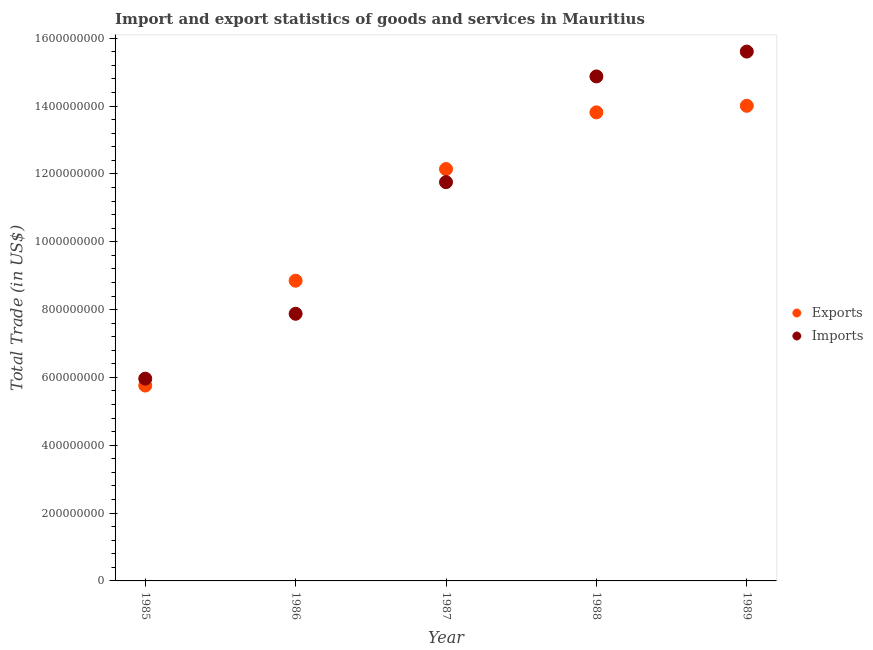How many different coloured dotlines are there?
Provide a succinct answer. 2. What is the imports of goods and services in 1985?
Keep it short and to the point. 5.96e+08. Across all years, what is the maximum imports of goods and services?
Keep it short and to the point. 1.56e+09. Across all years, what is the minimum imports of goods and services?
Give a very brief answer. 5.96e+08. In which year was the export of goods and services maximum?
Ensure brevity in your answer.  1989. In which year was the imports of goods and services minimum?
Your response must be concise. 1985. What is the total imports of goods and services in the graph?
Offer a very short reply. 5.61e+09. What is the difference between the export of goods and services in 1985 and that in 1988?
Your response must be concise. -8.06e+08. What is the difference between the export of goods and services in 1985 and the imports of goods and services in 1987?
Your answer should be very brief. -6.00e+08. What is the average imports of goods and services per year?
Your response must be concise. 1.12e+09. In the year 1989, what is the difference between the imports of goods and services and export of goods and services?
Ensure brevity in your answer.  1.60e+08. In how many years, is the export of goods and services greater than 1560000000 US$?
Your answer should be very brief. 0. What is the ratio of the imports of goods and services in 1986 to that in 1988?
Your answer should be very brief. 0.53. Is the imports of goods and services in 1985 less than that in 1987?
Offer a terse response. Yes. Is the difference between the imports of goods and services in 1987 and 1989 greater than the difference between the export of goods and services in 1987 and 1989?
Keep it short and to the point. No. What is the difference between the highest and the second highest export of goods and services?
Give a very brief answer. 1.93e+07. What is the difference between the highest and the lowest export of goods and services?
Ensure brevity in your answer.  8.25e+08. In how many years, is the imports of goods and services greater than the average imports of goods and services taken over all years?
Provide a short and direct response. 3. Is the sum of the export of goods and services in 1985 and 1986 greater than the maximum imports of goods and services across all years?
Offer a very short reply. No. Is the imports of goods and services strictly greater than the export of goods and services over the years?
Ensure brevity in your answer.  No. Is the imports of goods and services strictly less than the export of goods and services over the years?
Give a very brief answer. No. How many years are there in the graph?
Provide a succinct answer. 5. Does the graph contain grids?
Offer a terse response. No. What is the title of the graph?
Provide a short and direct response. Import and export statistics of goods and services in Mauritius. Does "DAC donors" appear as one of the legend labels in the graph?
Ensure brevity in your answer.  No. What is the label or title of the Y-axis?
Provide a succinct answer. Total Trade (in US$). What is the Total Trade (in US$) of Exports in 1985?
Offer a very short reply. 5.76e+08. What is the Total Trade (in US$) in Imports in 1985?
Offer a terse response. 5.96e+08. What is the Total Trade (in US$) of Exports in 1986?
Provide a succinct answer. 8.85e+08. What is the Total Trade (in US$) of Imports in 1986?
Your response must be concise. 7.88e+08. What is the Total Trade (in US$) of Exports in 1987?
Keep it short and to the point. 1.21e+09. What is the Total Trade (in US$) of Imports in 1987?
Your answer should be very brief. 1.18e+09. What is the Total Trade (in US$) in Exports in 1988?
Offer a very short reply. 1.38e+09. What is the Total Trade (in US$) of Imports in 1988?
Offer a terse response. 1.49e+09. What is the Total Trade (in US$) in Exports in 1989?
Offer a terse response. 1.40e+09. What is the Total Trade (in US$) in Imports in 1989?
Offer a terse response. 1.56e+09. Across all years, what is the maximum Total Trade (in US$) of Exports?
Ensure brevity in your answer.  1.40e+09. Across all years, what is the maximum Total Trade (in US$) in Imports?
Keep it short and to the point. 1.56e+09. Across all years, what is the minimum Total Trade (in US$) in Exports?
Keep it short and to the point. 5.76e+08. Across all years, what is the minimum Total Trade (in US$) of Imports?
Make the answer very short. 5.96e+08. What is the total Total Trade (in US$) of Exports in the graph?
Provide a succinct answer. 5.46e+09. What is the total Total Trade (in US$) in Imports in the graph?
Keep it short and to the point. 5.61e+09. What is the difference between the Total Trade (in US$) in Exports in 1985 and that in 1986?
Your answer should be very brief. -3.09e+08. What is the difference between the Total Trade (in US$) of Imports in 1985 and that in 1986?
Provide a short and direct response. -1.91e+08. What is the difference between the Total Trade (in US$) in Exports in 1985 and that in 1987?
Your response must be concise. -6.38e+08. What is the difference between the Total Trade (in US$) of Imports in 1985 and that in 1987?
Ensure brevity in your answer.  -5.79e+08. What is the difference between the Total Trade (in US$) of Exports in 1985 and that in 1988?
Keep it short and to the point. -8.06e+08. What is the difference between the Total Trade (in US$) of Imports in 1985 and that in 1988?
Keep it short and to the point. -8.91e+08. What is the difference between the Total Trade (in US$) in Exports in 1985 and that in 1989?
Offer a very short reply. -8.25e+08. What is the difference between the Total Trade (in US$) in Imports in 1985 and that in 1989?
Offer a terse response. -9.64e+08. What is the difference between the Total Trade (in US$) in Exports in 1986 and that in 1987?
Keep it short and to the point. -3.29e+08. What is the difference between the Total Trade (in US$) in Imports in 1986 and that in 1987?
Your answer should be very brief. -3.88e+08. What is the difference between the Total Trade (in US$) of Exports in 1986 and that in 1988?
Keep it short and to the point. -4.96e+08. What is the difference between the Total Trade (in US$) of Imports in 1986 and that in 1988?
Provide a succinct answer. -7.00e+08. What is the difference between the Total Trade (in US$) of Exports in 1986 and that in 1989?
Give a very brief answer. -5.16e+08. What is the difference between the Total Trade (in US$) in Imports in 1986 and that in 1989?
Offer a very short reply. -7.73e+08. What is the difference between the Total Trade (in US$) of Exports in 1987 and that in 1988?
Make the answer very short. -1.67e+08. What is the difference between the Total Trade (in US$) of Imports in 1987 and that in 1988?
Offer a very short reply. -3.12e+08. What is the difference between the Total Trade (in US$) of Exports in 1987 and that in 1989?
Give a very brief answer. -1.86e+08. What is the difference between the Total Trade (in US$) of Imports in 1987 and that in 1989?
Your response must be concise. -3.85e+08. What is the difference between the Total Trade (in US$) of Exports in 1988 and that in 1989?
Offer a very short reply. -1.93e+07. What is the difference between the Total Trade (in US$) in Imports in 1988 and that in 1989?
Your answer should be very brief. -7.33e+07. What is the difference between the Total Trade (in US$) of Exports in 1985 and the Total Trade (in US$) of Imports in 1986?
Your response must be concise. -2.12e+08. What is the difference between the Total Trade (in US$) in Exports in 1985 and the Total Trade (in US$) in Imports in 1987?
Give a very brief answer. -6.00e+08. What is the difference between the Total Trade (in US$) of Exports in 1985 and the Total Trade (in US$) of Imports in 1988?
Your answer should be very brief. -9.11e+08. What is the difference between the Total Trade (in US$) of Exports in 1985 and the Total Trade (in US$) of Imports in 1989?
Provide a succinct answer. -9.85e+08. What is the difference between the Total Trade (in US$) in Exports in 1986 and the Total Trade (in US$) in Imports in 1987?
Offer a very short reply. -2.91e+08. What is the difference between the Total Trade (in US$) in Exports in 1986 and the Total Trade (in US$) in Imports in 1988?
Ensure brevity in your answer.  -6.02e+08. What is the difference between the Total Trade (in US$) in Exports in 1986 and the Total Trade (in US$) in Imports in 1989?
Ensure brevity in your answer.  -6.76e+08. What is the difference between the Total Trade (in US$) in Exports in 1987 and the Total Trade (in US$) in Imports in 1988?
Your answer should be very brief. -2.73e+08. What is the difference between the Total Trade (in US$) in Exports in 1987 and the Total Trade (in US$) in Imports in 1989?
Offer a very short reply. -3.46e+08. What is the difference between the Total Trade (in US$) of Exports in 1988 and the Total Trade (in US$) of Imports in 1989?
Your answer should be very brief. -1.79e+08. What is the average Total Trade (in US$) of Exports per year?
Make the answer very short. 1.09e+09. What is the average Total Trade (in US$) in Imports per year?
Ensure brevity in your answer.  1.12e+09. In the year 1985, what is the difference between the Total Trade (in US$) in Exports and Total Trade (in US$) in Imports?
Provide a succinct answer. -2.04e+07. In the year 1986, what is the difference between the Total Trade (in US$) in Exports and Total Trade (in US$) in Imports?
Give a very brief answer. 9.74e+07. In the year 1987, what is the difference between the Total Trade (in US$) in Exports and Total Trade (in US$) in Imports?
Ensure brevity in your answer.  3.87e+07. In the year 1988, what is the difference between the Total Trade (in US$) of Exports and Total Trade (in US$) of Imports?
Offer a very short reply. -1.06e+08. In the year 1989, what is the difference between the Total Trade (in US$) of Exports and Total Trade (in US$) of Imports?
Your answer should be very brief. -1.60e+08. What is the ratio of the Total Trade (in US$) of Exports in 1985 to that in 1986?
Your response must be concise. 0.65. What is the ratio of the Total Trade (in US$) in Imports in 1985 to that in 1986?
Give a very brief answer. 0.76. What is the ratio of the Total Trade (in US$) in Exports in 1985 to that in 1987?
Offer a terse response. 0.47. What is the ratio of the Total Trade (in US$) in Imports in 1985 to that in 1987?
Provide a short and direct response. 0.51. What is the ratio of the Total Trade (in US$) in Exports in 1985 to that in 1988?
Provide a short and direct response. 0.42. What is the ratio of the Total Trade (in US$) in Imports in 1985 to that in 1988?
Your answer should be compact. 0.4. What is the ratio of the Total Trade (in US$) in Exports in 1985 to that in 1989?
Offer a very short reply. 0.41. What is the ratio of the Total Trade (in US$) in Imports in 1985 to that in 1989?
Give a very brief answer. 0.38. What is the ratio of the Total Trade (in US$) of Exports in 1986 to that in 1987?
Ensure brevity in your answer.  0.73. What is the ratio of the Total Trade (in US$) of Imports in 1986 to that in 1987?
Offer a terse response. 0.67. What is the ratio of the Total Trade (in US$) in Exports in 1986 to that in 1988?
Your answer should be very brief. 0.64. What is the ratio of the Total Trade (in US$) of Imports in 1986 to that in 1988?
Offer a very short reply. 0.53. What is the ratio of the Total Trade (in US$) of Exports in 1986 to that in 1989?
Ensure brevity in your answer.  0.63. What is the ratio of the Total Trade (in US$) in Imports in 1986 to that in 1989?
Your response must be concise. 0.5. What is the ratio of the Total Trade (in US$) in Exports in 1987 to that in 1988?
Give a very brief answer. 0.88. What is the ratio of the Total Trade (in US$) of Imports in 1987 to that in 1988?
Keep it short and to the point. 0.79. What is the ratio of the Total Trade (in US$) of Exports in 1987 to that in 1989?
Give a very brief answer. 0.87. What is the ratio of the Total Trade (in US$) of Imports in 1987 to that in 1989?
Give a very brief answer. 0.75. What is the ratio of the Total Trade (in US$) in Exports in 1988 to that in 1989?
Make the answer very short. 0.99. What is the ratio of the Total Trade (in US$) of Imports in 1988 to that in 1989?
Offer a terse response. 0.95. What is the difference between the highest and the second highest Total Trade (in US$) of Exports?
Provide a succinct answer. 1.93e+07. What is the difference between the highest and the second highest Total Trade (in US$) in Imports?
Offer a very short reply. 7.33e+07. What is the difference between the highest and the lowest Total Trade (in US$) in Exports?
Provide a succinct answer. 8.25e+08. What is the difference between the highest and the lowest Total Trade (in US$) in Imports?
Offer a very short reply. 9.64e+08. 